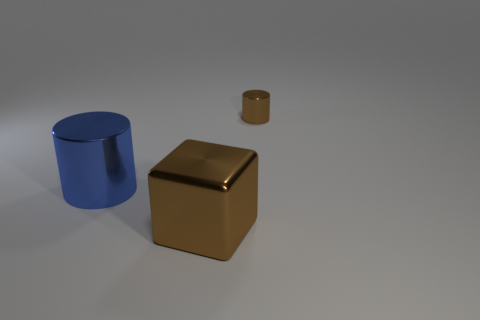Add 2 tiny brown metal cylinders. How many objects exist? 5 Subtract 1 cylinders. How many cylinders are left? 1 Subtract all brown cylinders. How many cylinders are left? 1 Subtract 1 blue cylinders. How many objects are left? 2 Subtract all cubes. How many objects are left? 2 Subtract all yellow cylinders. Subtract all cyan cubes. How many cylinders are left? 2 Subtract all blue cubes. How many brown cylinders are left? 1 Subtract all brown spheres. Subtract all blue cylinders. How many objects are left? 2 Add 3 big blue shiny things. How many big blue shiny things are left? 4 Add 1 cylinders. How many cylinders exist? 3 